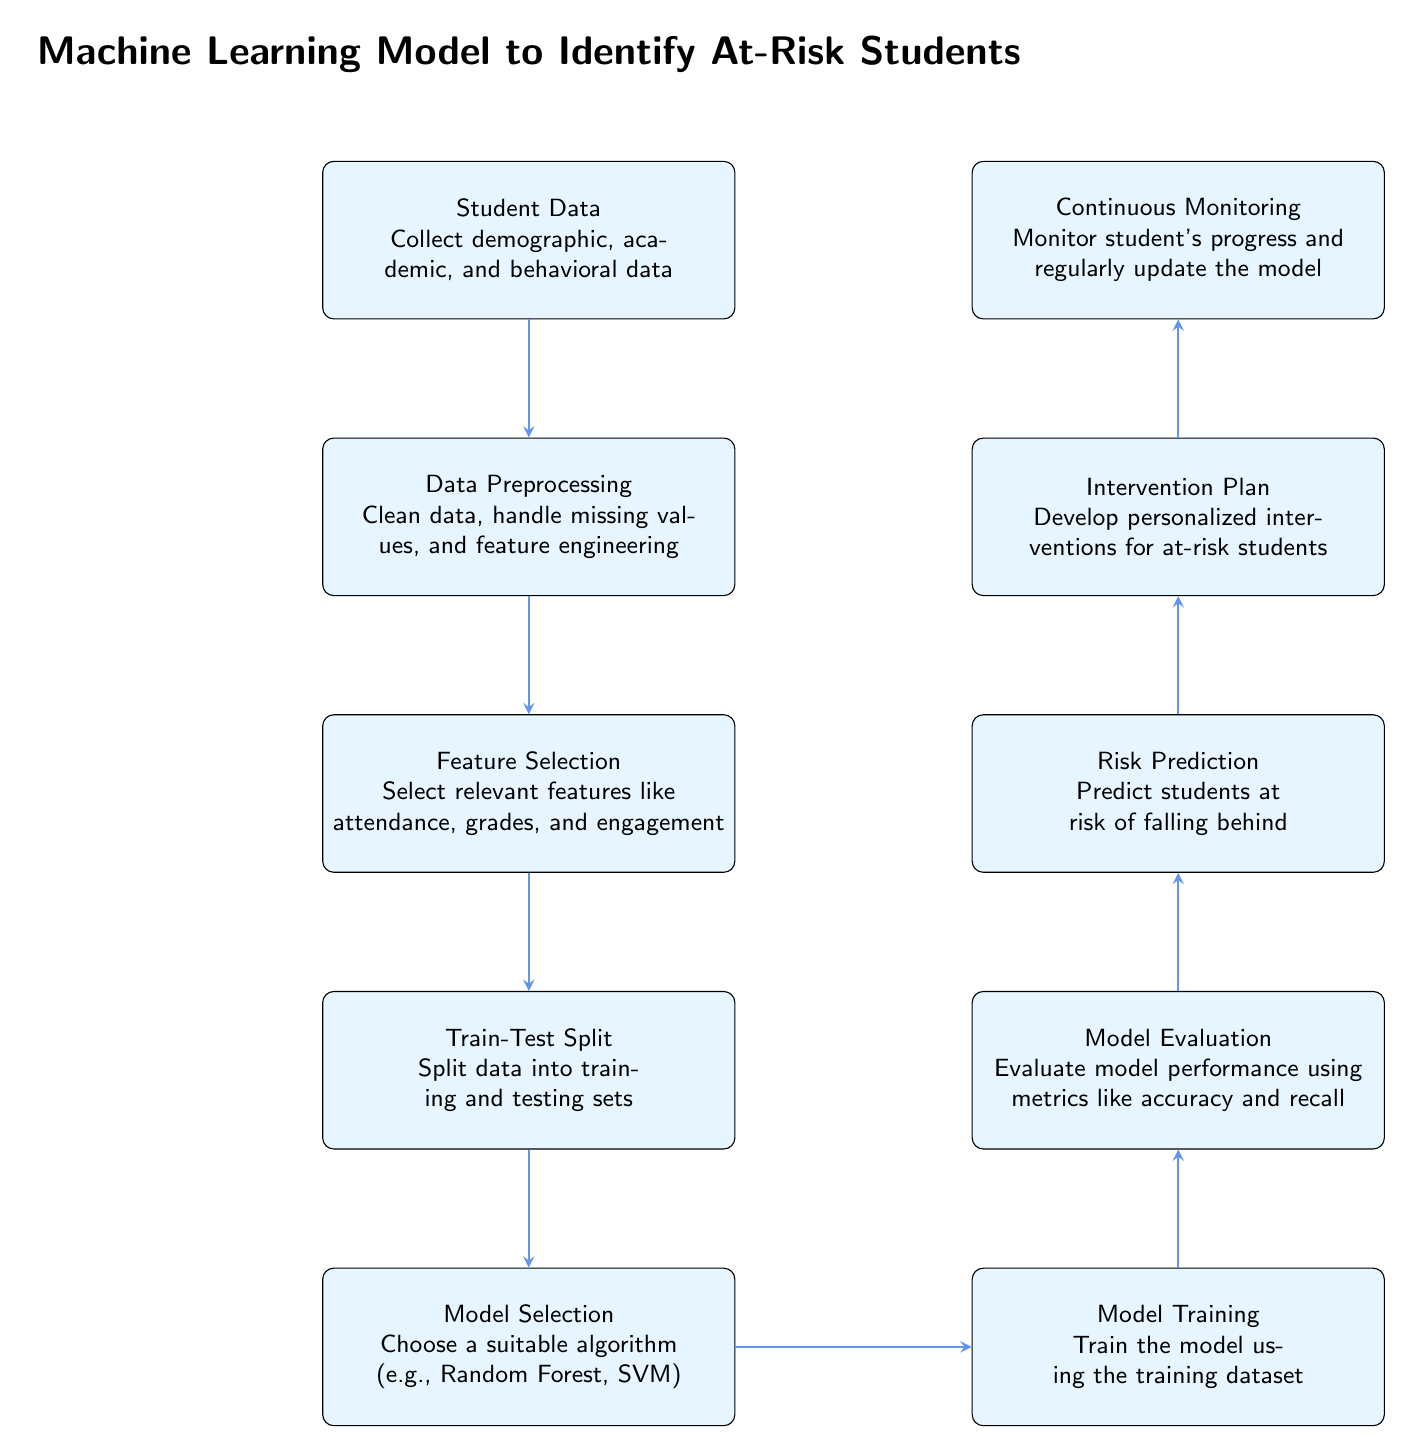What's the first step in the machine learning model process? The first step is labeled as "Student Data," which details the collection of demographic, academic, and behavioral data.
Answer: Student Data How many boxes are there in the diagram? By counting all the labeled boxes, including "Student Data" to "Continuous Monitoring," there are a total of 9 boxes in the diagram.
Answer: 9 What is the main purpose of the "Continuous Monitoring" box? "Continuous Monitoring" is designed to monitor student's progress and regularly update the model, ensuring it stays relevant and effective.
Answer: Monitor student's progress Which box comes after "Model Training" in the flow? The box that follows "Model Training" is "Model Evaluation," which assesses the model's performance with various metrics.
Answer: Model Evaluation What features are selected in the "Feature Selection" step? The "Feature Selection" step refers to selecting relevant features like attendance, grades, and engagement, which are integral for training the model.
Answer: Attendance, grades, and engagement What is the outcome of the "Risk Prediction" box? The outcome of the "Risk Prediction" box is the identification of students at risk of falling behind, which is critical for timely intervention.
Answer: Predict students at risk of falling behind How does "Intervention Plan" relate to "Risk Prediction"? The "Intervention Plan" follows "Risk Prediction" and is developed based on the predictions made regarding at-risk students to provide personalized interventions.
Answer: Develop personalized interventions What algorithm types might be chosen in "Model Selection"? The "Model Selection" step indicates that suitable algorithms may include Random Forest or Support Vector Machine.
Answer: Random Forest, SVM What happens before "Model Training"? "Model Training" occurs after the "Train-Test Split," where the data is divided into training and testing sets for effective model building.
Answer: Train-Test Split 